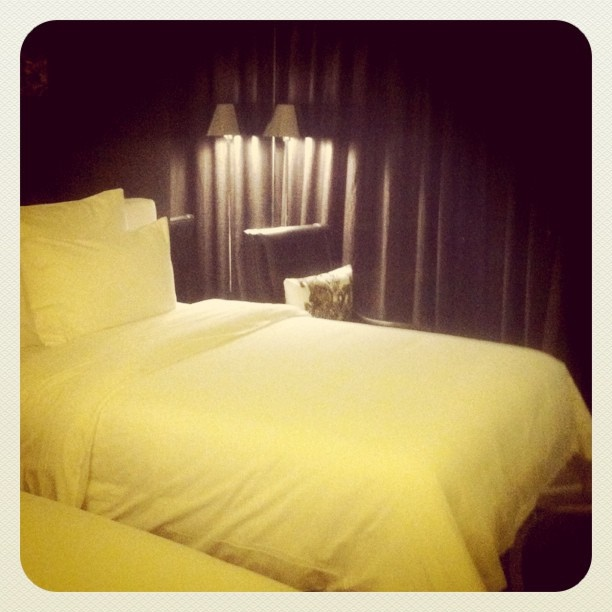Describe the objects in this image and their specific colors. I can see bed in ivory, khaki, tan, and olive tones, bed in ivory, gold, and olive tones, chair in ivory, gray, tan, and brown tones, and chair in ivory, maroon, and brown tones in this image. 